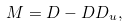Convert formula to latex. <formula><loc_0><loc_0><loc_500><loc_500>M = D - D D _ { u } ,</formula> 